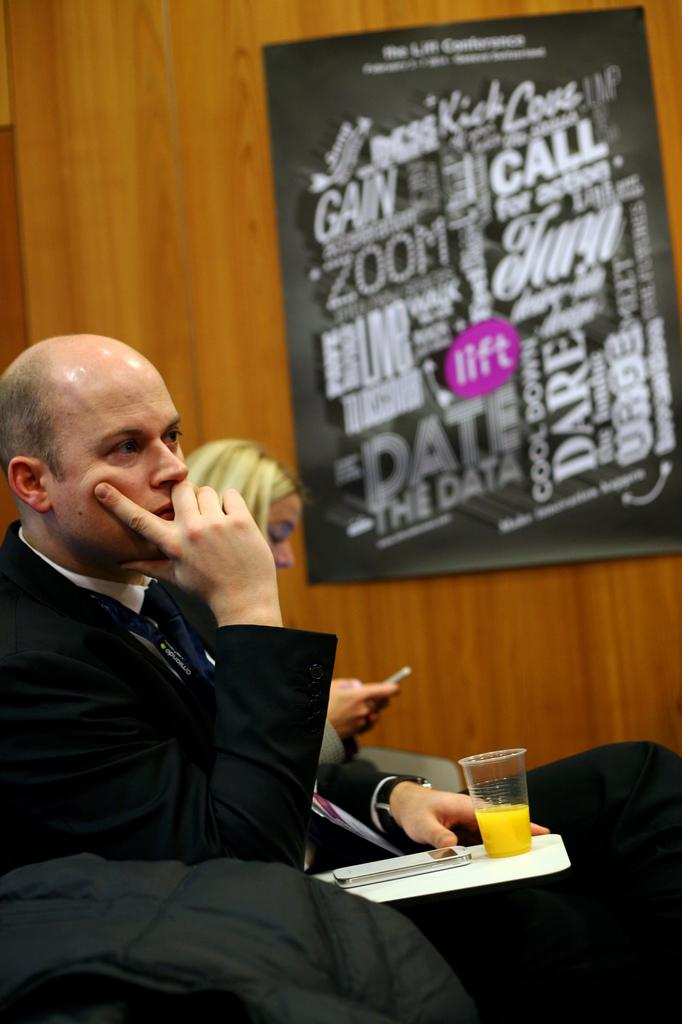<image>
Give a short and clear explanation of the subsequent image. A man and woman are sitting at an event by a poster that says lift. 